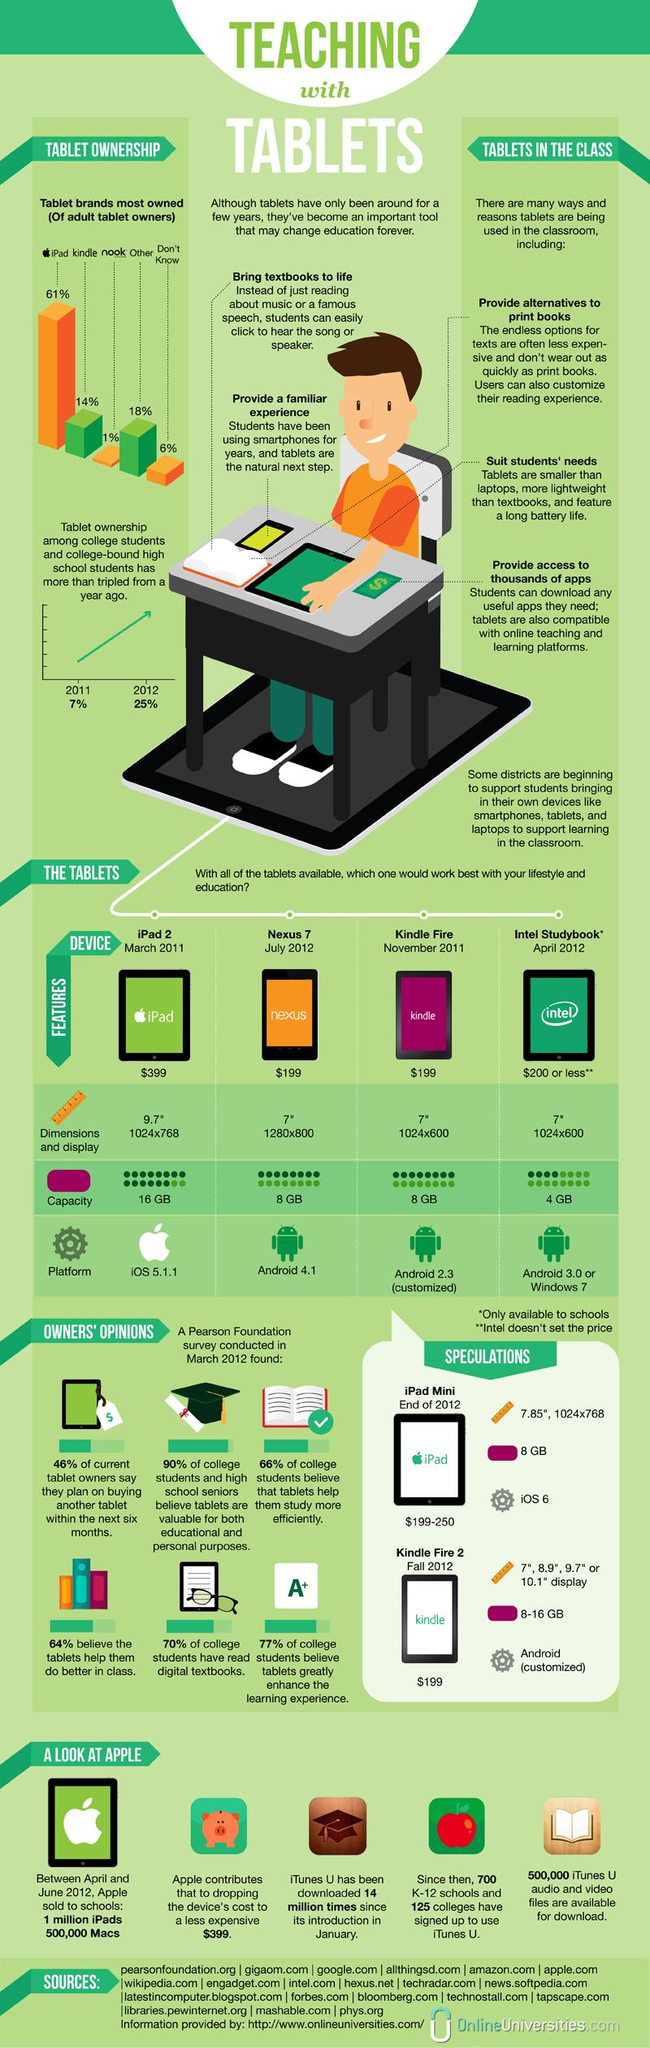Indicate a few pertinent items in this graphic. The Nexus 7 uses the Android 4.1 operating system. Nook is the tablet brand that is least owned by adults. Kindle Fire has a capacity of 8 gigabytes. The iPad 2 has a capacity of 16 GB. The percentage growth of tablet owners among college students and college-bound high school students from 2011 to 2012 was 18%. 